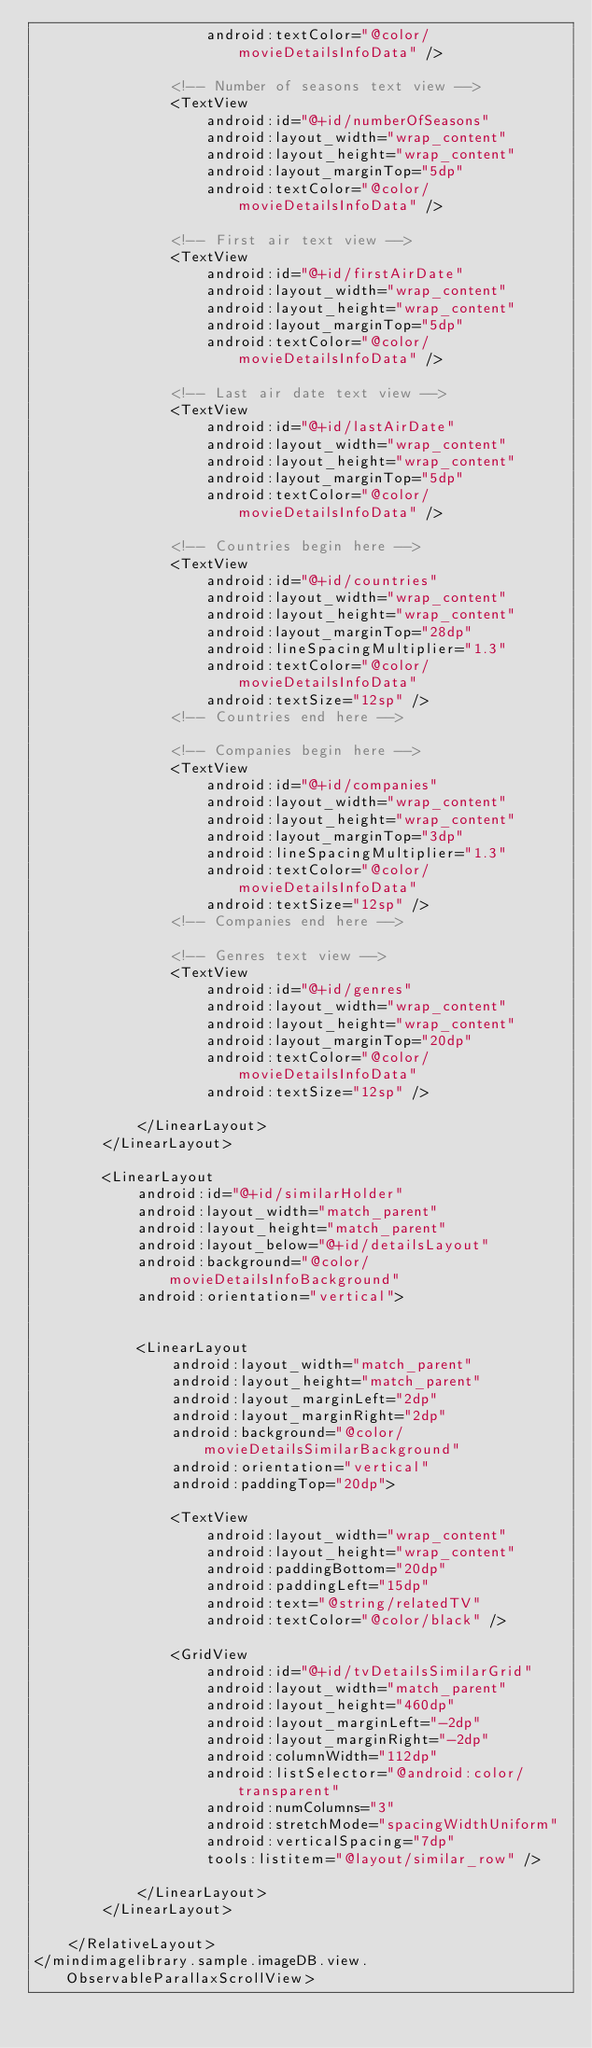Convert code to text. <code><loc_0><loc_0><loc_500><loc_500><_XML_>                    android:textColor="@color/movieDetailsInfoData" />

                <!-- Number of seasons text view -->
                <TextView
                    android:id="@+id/numberOfSeasons"
                    android:layout_width="wrap_content"
                    android:layout_height="wrap_content"
                    android:layout_marginTop="5dp"
                    android:textColor="@color/movieDetailsInfoData" />

                <!-- First air text view -->
                <TextView
                    android:id="@+id/firstAirDate"
                    android:layout_width="wrap_content"
                    android:layout_height="wrap_content"
                    android:layout_marginTop="5dp"
                    android:textColor="@color/movieDetailsInfoData" />

                <!-- Last air date text view -->
                <TextView
                    android:id="@+id/lastAirDate"
                    android:layout_width="wrap_content"
                    android:layout_height="wrap_content"
                    android:layout_marginTop="5dp"
                    android:textColor="@color/movieDetailsInfoData" />

                <!-- Countries begin here -->
                <TextView
                    android:id="@+id/countries"
                    android:layout_width="wrap_content"
                    android:layout_height="wrap_content"
                    android:layout_marginTop="28dp"
                    android:lineSpacingMultiplier="1.3"
                    android:textColor="@color/movieDetailsInfoData"
                    android:textSize="12sp" />
                <!-- Countries end here -->

                <!-- Companies begin here -->
                <TextView
                    android:id="@+id/companies"
                    android:layout_width="wrap_content"
                    android:layout_height="wrap_content"
                    android:layout_marginTop="3dp"
                    android:lineSpacingMultiplier="1.3"
                    android:textColor="@color/movieDetailsInfoData"
                    android:textSize="12sp" />
                <!-- Companies end here -->

                <!-- Genres text view -->
                <TextView
                    android:id="@+id/genres"
                    android:layout_width="wrap_content"
                    android:layout_height="wrap_content"
                    android:layout_marginTop="20dp"
                    android:textColor="@color/movieDetailsInfoData"
                    android:textSize="12sp" />

            </LinearLayout>
        </LinearLayout>

        <LinearLayout
            android:id="@+id/similarHolder"
            android:layout_width="match_parent"
            android:layout_height="match_parent"
            android:layout_below="@+id/detailsLayout"
            android:background="@color/movieDetailsInfoBackground"
            android:orientation="vertical">


            <LinearLayout
                android:layout_width="match_parent"
                android:layout_height="match_parent"
                android:layout_marginLeft="2dp"
                android:layout_marginRight="2dp"
                android:background="@color/movieDetailsSimilarBackground"
                android:orientation="vertical"
                android:paddingTop="20dp">

                <TextView
                    android:layout_width="wrap_content"
                    android:layout_height="wrap_content"
                    android:paddingBottom="20dp"
                    android:paddingLeft="15dp"
                    android:text="@string/relatedTV"
                    android:textColor="@color/black" />

                <GridView
                    android:id="@+id/tvDetailsSimilarGrid"
                    android:layout_width="match_parent"
                    android:layout_height="460dp"
                    android:layout_marginLeft="-2dp"
                    android:layout_marginRight="-2dp"
                    android:columnWidth="112dp"
                    android:listSelector="@android:color/transparent"
                    android:numColumns="3"
                    android:stretchMode="spacingWidthUniform"
                    android:verticalSpacing="7dp"
                    tools:listitem="@layout/similar_row" />

            </LinearLayout>
        </LinearLayout>

    </RelativeLayout>
</mindimagelibrary.sample.imageDB.view.ObservableParallaxScrollView></code> 